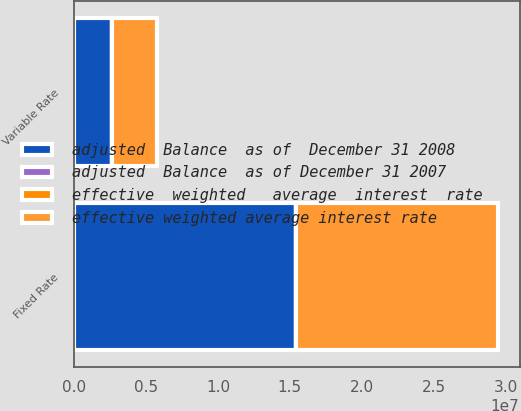Convert chart to OTSL. <chart><loc_0><loc_0><loc_500><loc_500><stacked_bar_chart><ecel><fcel>Fixed Rate<fcel>Variable Rate<nl><fcel>adjusted  Balance  as of  December 31 2008<fcel>1.54243e+07<fcel>2.61821e+06<nl><fcel>adjusted  Balance  as of December 31 2007<fcel>5.76<fcel>1.31<nl><fcel>effective weighted average interest rate<fcel>1.4056e+07<fcel>3.16267e+06<nl><fcel>effective  weighted   average  interest  rate<fcel>5.88<fcel>4.73<nl></chart> 